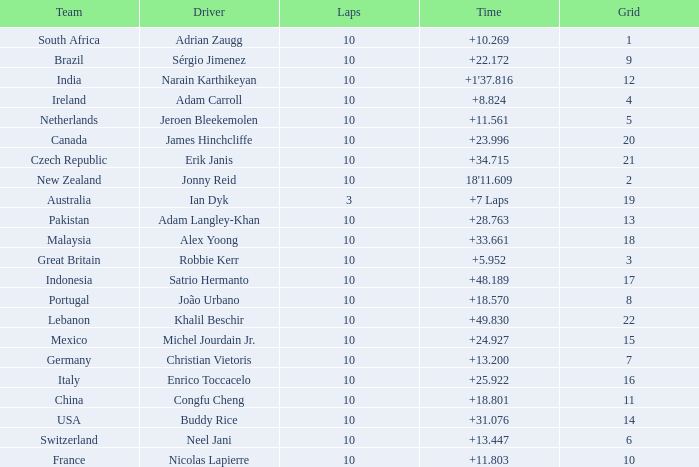For what Team is Narain Karthikeyan the Driver? India. 